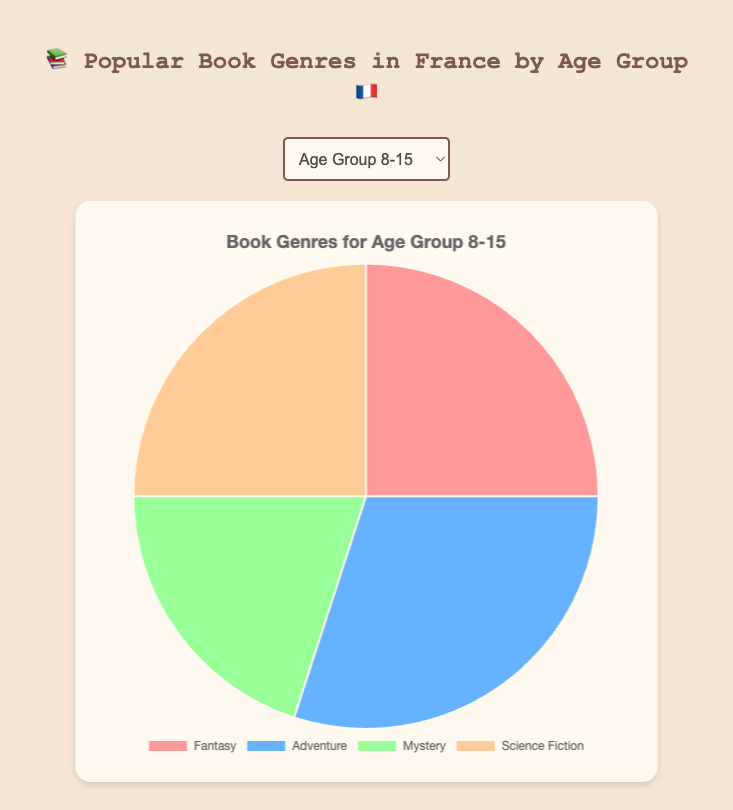Which genre is most popular among the 8-15 age group? The 8-15 age group has the highest percentage for Adventure at 30%.
Answer: Adventure Compare the popularity of Mystery between the 8-15 and 60+ age groups. Mystery is at 20% in the 8-15 age group and 15% in the 60+ age group, so it is more popular among the 8-15 age group.
Answer: More popular in 8-15 age group What is the combined percentage for Fantasy and Science Fiction in the 8-15 age group? The percentage for Fantasy is 25% and for Science Fiction is 25%, so the combined percentage is 25% + 25% = 50%.
Answer: 50% Which age group shows the highest percentage for Romance? The age group 16-25 has the highest percentage for Romance at 35%.
Answer: 16-25 What is the difference in percentage between Young Adult and Romance in the 16-25 age group? Romance is at 35% and Young Adult is at 25%, so the difference is 35% - 25% = 10%.
Answer: 10% Which genre is equally popular in the 41-60 age group? Both Thriller and Non-Fiction are at 25% in the 41-60 age group.
Answer: Thriller and Non-Fiction How does the percentage for Historical Fiction compare between the 26-40 and 60+ age groups? Historical Fiction is at 25% in the 26-40 age group and 35% in the 60+ age group, so it is more popular in the 60+ age group.
Answer: More popular in 60+ age group What is the total percentage of genres other than Literary Fiction in the 41-60 age group? Literary Fiction is at 20%, so the total percentage for other genres is 100% - 20% = 80%.
Answer: 80% Which genre has equal representation in both Fantasy and Science Fiction for the 8-15 age group and Thriller and Non-Fiction for the 41-60 age group, and what is that percentage? Both Fantasy and Science Fiction in the 8-15 age group are at 25%, and both Thriller and Non-Fiction in the 41-60 age group are also at 25%.
Answer: 25% What's the average popularity of Historical Fiction across all age groups? The percentages for Historical Fiction are: 0% (8-15), 0% (16-25), 25% (26-40), 30% (41-60), 35% (60+). The sum is 0 + 0 + 25 + 30 + 35 = 90, divided by 5, the average is 90/5 = 18%.
Answer: 18% 